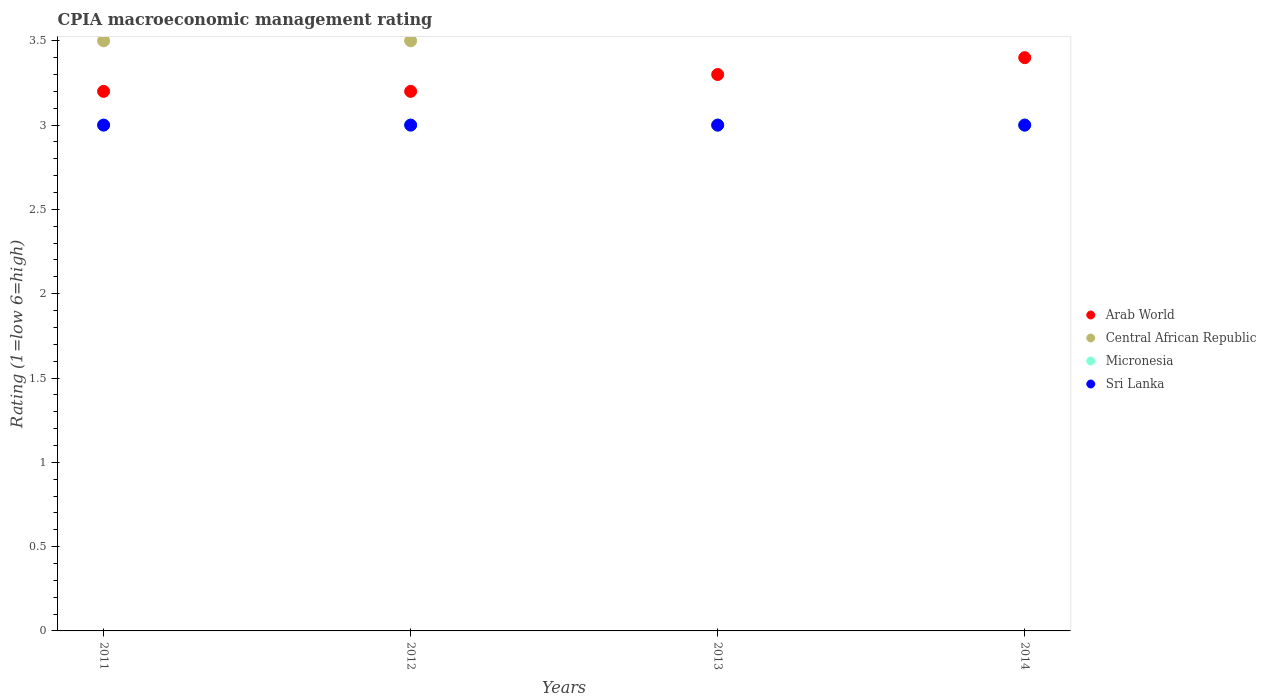How many different coloured dotlines are there?
Provide a succinct answer. 4. Across all years, what is the minimum CPIA rating in Arab World?
Keep it short and to the point. 3.2. In which year was the CPIA rating in Micronesia maximum?
Offer a very short reply. 2011. What is the total CPIA rating in Micronesia in the graph?
Provide a short and direct response. 12. What is the difference between the CPIA rating in Arab World in 2014 and the CPIA rating in Sri Lanka in 2012?
Keep it short and to the point. 0.4. What is the average CPIA rating in Micronesia per year?
Your response must be concise. 3. In the year 2011, what is the difference between the CPIA rating in Sri Lanka and CPIA rating in Arab World?
Provide a short and direct response. -0.2. In how many years, is the CPIA rating in Arab World greater than 2.8?
Ensure brevity in your answer.  4. What is the ratio of the CPIA rating in Micronesia in 2011 to that in 2014?
Your answer should be very brief. 1. Is the CPIA rating in Micronesia in 2011 less than that in 2014?
Your answer should be very brief. No. What is the difference between the highest and the second highest CPIA rating in Central African Republic?
Give a very brief answer. 0. What is the difference between the highest and the lowest CPIA rating in Central African Republic?
Your answer should be compact. 0.5. Is it the case that in every year, the sum of the CPIA rating in Arab World and CPIA rating in Sri Lanka  is greater than the CPIA rating in Micronesia?
Provide a succinct answer. Yes. Does the CPIA rating in Central African Republic monotonically increase over the years?
Give a very brief answer. No. Is the CPIA rating in Sri Lanka strictly greater than the CPIA rating in Central African Republic over the years?
Offer a very short reply. No. What is the difference between two consecutive major ticks on the Y-axis?
Ensure brevity in your answer.  0.5. Does the graph contain any zero values?
Provide a succinct answer. No. Does the graph contain grids?
Your answer should be compact. No. How many legend labels are there?
Ensure brevity in your answer.  4. What is the title of the graph?
Give a very brief answer. CPIA macroeconomic management rating. What is the label or title of the Y-axis?
Your response must be concise. Rating (1=low 6=high). What is the Rating (1=low 6=high) in Micronesia in 2011?
Make the answer very short. 3. What is the Rating (1=low 6=high) of Central African Republic in 2012?
Ensure brevity in your answer.  3.5. What is the Rating (1=low 6=high) in Micronesia in 2012?
Ensure brevity in your answer.  3. What is the Rating (1=low 6=high) in Sri Lanka in 2012?
Provide a short and direct response. 3. What is the Rating (1=low 6=high) in Central African Republic in 2013?
Give a very brief answer. 3. What is the Rating (1=low 6=high) of Micronesia in 2013?
Your answer should be compact. 3. What is the Rating (1=low 6=high) in Sri Lanka in 2013?
Your answer should be very brief. 3. What is the Rating (1=low 6=high) of Micronesia in 2014?
Make the answer very short. 3. Across all years, what is the maximum Rating (1=low 6=high) of Arab World?
Your response must be concise. 3.4. Across all years, what is the maximum Rating (1=low 6=high) of Central African Republic?
Offer a very short reply. 3.5. Across all years, what is the maximum Rating (1=low 6=high) in Sri Lanka?
Provide a succinct answer. 3. Across all years, what is the minimum Rating (1=low 6=high) in Sri Lanka?
Give a very brief answer. 3. What is the total Rating (1=low 6=high) in Sri Lanka in the graph?
Offer a terse response. 12. What is the difference between the Rating (1=low 6=high) in Central African Republic in 2011 and that in 2012?
Offer a terse response. 0. What is the difference between the Rating (1=low 6=high) in Micronesia in 2011 and that in 2012?
Give a very brief answer. 0. What is the difference between the Rating (1=low 6=high) of Sri Lanka in 2011 and that in 2013?
Make the answer very short. 0. What is the difference between the Rating (1=low 6=high) of Arab World in 2011 and that in 2014?
Provide a succinct answer. -0.2. What is the difference between the Rating (1=low 6=high) of Central African Republic in 2011 and that in 2014?
Offer a very short reply. 0.5. What is the difference between the Rating (1=low 6=high) of Sri Lanka in 2011 and that in 2014?
Your response must be concise. 0. What is the difference between the Rating (1=low 6=high) of Arab World in 2012 and that in 2013?
Your answer should be very brief. -0.1. What is the difference between the Rating (1=low 6=high) in Micronesia in 2012 and that in 2013?
Offer a terse response. 0. What is the difference between the Rating (1=low 6=high) in Sri Lanka in 2012 and that in 2013?
Provide a short and direct response. 0. What is the difference between the Rating (1=low 6=high) in Central African Republic in 2012 and that in 2014?
Give a very brief answer. 0.5. What is the difference between the Rating (1=low 6=high) of Sri Lanka in 2012 and that in 2014?
Your answer should be compact. 0. What is the difference between the Rating (1=low 6=high) of Sri Lanka in 2013 and that in 2014?
Your answer should be very brief. 0. What is the difference between the Rating (1=low 6=high) of Arab World in 2011 and the Rating (1=low 6=high) of Micronesia in 2012?
Ensure brevity in your answer.  0.2. What is the difference between the Rating (1=low 6=high) in Central African Republic in 2011 and the Rating (1=low 6=high) in Micronesia in 2012?
Keep it short and to the point. 0.5. What is the difference between the Rating (1=low 6=high) in Central African Republic in 2011 and the Rating (1=low 6=high) in Sri Lanka in 2012?
Your answer should be very brief. 0.5. What is the difference between the Rating (1=low 6=high) of Arab World in 2011 and the Rating (1=low 6=high) of Central African Republic in 2013?
Provide a short and direct response. 0.2. What is the difference between the Rating (1=low 6=high) in Arab World in 2011 and the Rating (1=low 6=high) in Micronesia in 2013?
Provide a succinct answer. 0.2. What is the difference between the Rating (1=low 6=high) in Arab World in 2011 and the Rating (1=low 6=high) in Sri Lanka in 2013?
Your answer should be very brief. 0.2. What is the difference between the Rating (1=low 6=high) of Central African Republic in 2011 and the Rating (1=low 6=high) of Sri Lanka in 2013?
Keep it short and to the point. 0.5. What is the difference between the Rating (1=low 6=high) in Micronesia in 2011 and the Rating (1=low 6=high) in Sri Lanka in 2013?
Give a very brief answer. 0. What is the difference between the Rating (1=low 6=high) of Arab World in 2011 and the Rating (1=low 6=high) of Micronesia in 2014?
Keep it short and to the point. 0.2. What is the difference between the Rating (1=low 6=high) in Central African Republic in 2011 and the Rating (1=low 6=high) in Micronesia in 2014?
Offer a terse response. 0.5. What is the difference between the Rating (1=low 6=high) in Central African Republic in 2011 and the Rating (1=low 6=high) in Sri Lanka in 2014?
Make the answer very short. 0.5. What is the difference between the Rating (1=low 6=high) of Arab World in 2012 and the Rating (1=low 6=high) of Central African Republic in 2013?
Your answer should be very brief. 0.2. What is the difference between the Rating (1=low 6=high) in Arab World in 2012 and the Rating (1=low 6=high) in Central African Republic in 2014?
Your answer should be compact. 0.2. What is the difference between the Rating (1=low 6=high) of Arab World in 2012 and the Rating (1=low 6=high) of Micronesia in 2014?
Your answer should be compact. 0.2. What is the difference between the Rating (1=low 6=high) of Central African Republic in 2012 and the Rating (1=low 6=high) of Micronesia in 2014?
Offer a very short reply. 0.5. What is the difference between the Rating (1=low 6=high) in Micronesia in 2012 and the Rating (1=low 6=high) in Sri Lanka in 2014?
Provide a short and direct response. 0. What is the difference between the Rating (1=low 6=high) in Micronesia in 2013 and the Rating (1=low 6=high) in Sri Lanka in 2014?
Your answer should be compact. 0. What is the average Rating (1=low 6=high) in Arab World per year?
Your response must be concise. 3.27. What is the average Rating (1=low 6=high) in Central African Republic per year?
Ensure brevity in your answer.  3.25. What is the average Rating (1=low 6=high) in Micronesia per year?
Offer a terse response. 3. In the year 2011, what is the difference between the Rating (1=low 6=high) in Arab World and Rating (1=low 6=high) in Central African Republic?
Provide a short and direct response. -0.3. In the year 2011, what is the difference between the Rating (1=low 6=high) in Arab World and Rating (1=low 6=high) in Micronesia?
Give a very brief answer. 0.2. In the year 2011, what is the difference between the Rating (1=low 6=high) in Arab World and Rating (1=low 6=high) in Sri Lanka?
Ensure brevity in your answer.  0.2. In the year 2011, what is the difference between the Rating (1=low 6=high) in Central African Republic and Rating (1=low 6=high) in Micronesia?
Your answer should be compact. 0.5. In the year 2011, what is the difference between the Rating (1=low 6=high) of Central African Republic and Rating (1=low 6=high) of Sri Lanka?
Ensure brevity in your answer.  0.5. In the year 2011, what is the difference between the Rating (1=low 6=high) of Micronesia and Rating (1=low 6=high) of Sri Lanka?
Your response must be concise. 0. In the year 2012, what is the difference between the Rating (1=low 6=high) in Arab World and Rating (1=low 6=high) in Central African Republic?
Ensure brevity in your answer.  -0.3. In the year 2012, what is the difference between the Rating (1=low 6=high) in Arab World and Rating (1=low 6=high) in Micronesia?
Your response must be concise. 0.2. In the year 2013, what is the difference between the Rating (1=low 6=high) of Arab World and Rating (1=low 6=high) of Sri Lanka?
Ensure brevity in your answer.  0.3. In the year 2014, what is the difference between the Rating (1=low 6=high) in Arab World and Rating (1=low 6=high) in Central African Republic?
Provide a succinct answer. 0.4. In the year 2014, what is the difference between the Rating (1=low 6=high) in Central African Republic and Rating (1=low 6=high) in Micronesia?
Your answer should be compact. 0. In the year 2014, what is the difference between the Rating (1=low 6=high) in Central African Republic and Rating (1=low 6=high) in Sri Lanka?
Make the answer very short. 0. In the year 2014, what is the difference between the Rating (1=low 6=high) in Micronesia and Rating (1=low 6=high) in Sri Lanka?
Offer a terse response. 0. What is the ratio of the Rating (1=low 6=high) of Arab World in 2011 to that in 2012?
Offer a terse response. 1. What is the ratio of the Rating (1=low 6=high) of Central African Republic in 2011 to that in 2012?
Keep it short and to the point. 1. What is the ratio of the Rating (1=low 6=high) of Sri Lanka in 2011 to that in 2012?
Your response must be concise. 1. What is the ratio of the Rating (1=low 6=high) in Arab World in 2011 to that in 2013?
Offer a very short reply. 0.97. What is the ratio of the Rating (1=low 6=high) of Central African Republic in 2011 to that in 2014?
Offer a terse response. 1.17. What is the ratio of the Rating (1=low 6=high) of Arab World in 2012 to that in 2013?
Your answer should be very brief. 0.97. What is the ratio of the Rating (1=low 6=high) in Arab World in 2013 to that in 2014?
Provide a short and direct response. 0.97. What is the ratio of the Rating (1=low 6=high) in Micronesia in 2013 to that in 2014?
Provide a short and direct response. 1. What is the ratio of the Rating (1=low 6=high) of Sri Lanka in 2013 to that in 2014?
Give a very brief answer. 1. What is the difference between the highest and the second highest Rating (1=low 6=high) of Central African Republic?
Offer a terse response. 0. What is the difference between the highest and the second highest Rating (1=low 6=high) in Sri Lanka?
Provide a succinct answer. 0. What is the difference between the highest and the lowest Rating (1=low 6=high) in Arab World?
Make the answer very short. 0.2. What is the difference between the highest and the lowest Rating (1=low 6=high) of Sri Lanka?
Your response must be concise. 0. 